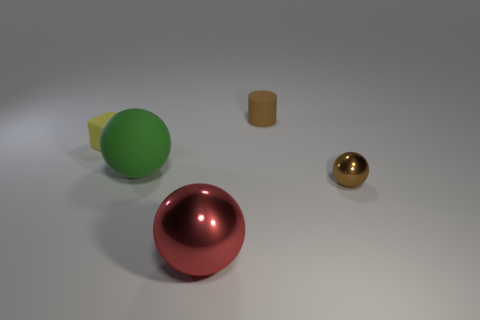There is another rubber object that is the same shape as the red thing; what color is it?
Your answer should be compact. Green. There is a object that is behind the big green thing and left of the big red shiny ball; what is its shape?
Offer a terse response. Cube. Are there more red metallic objects than brown objects?
Your answer should be very brief. No. What is the material of the red ball?
Offer a terse response. Metal. There is a red metallic object that is the same shape as the brown metal thing; what size is it?
Offer a very short reply. Large. There is a small object that is in front of the yellow block; is there a tiny yellow rubber thing that is right of it?
Offer a very short reply. No. Is the color of the tiny metal object the same as the small cylinder?
Ensure brevity in your answer.  Yes. How many other objects are the same shape as the small brown matte thing?
Your answer should be very brief. 0. Is the number of rubber objects on the left side of the brown matte thing greater than the number of small yellow matte things that are on the right side of the big metallic thing?
Ensure brevity in your answer.  Yes. There is a yellow matte object in front of the small brown rubber object; does it have the same size as the brown object that is on the left side of the brown metallic thing?
Provide a succinct answer. Yes. 